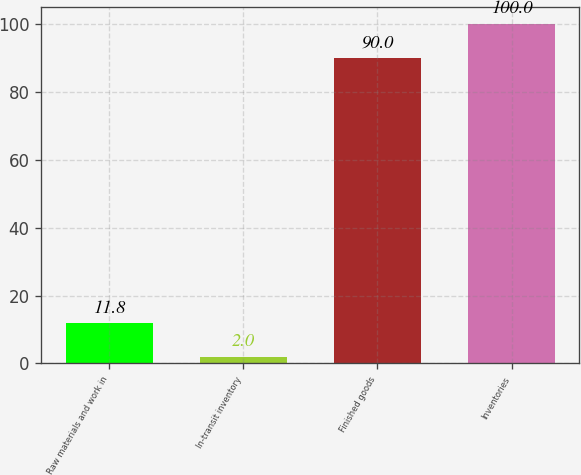<chart> <loc_0><loc_0><loc_500><loc_500><bar_chart><fcel>Raw materials and work in<fcel>In-transit inventory<fcel>Finished goods<fcel>Inventories<nl><fcel>11.8<fcel>2<fcel>90<fcel>100<nl></chart> 